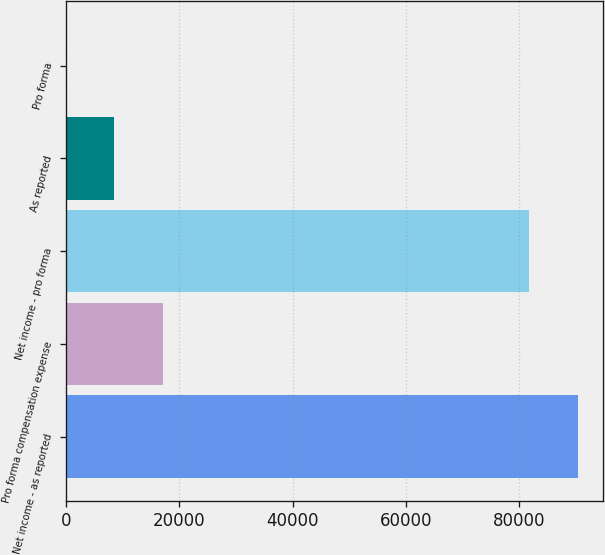<chart> <loc_0><loc_0><loc_500><loc_500><bar_chart><fcel>Net income - as reported<fcel>Pro forma compensation expense<fcel>Net income - pro forma<fcel>As reported<fcel>Pro forma<nl><fcel>90292.7<fcel>17135.5<fcel>81726<fcel>8568.78<fcel>2.09<nl></chart> 